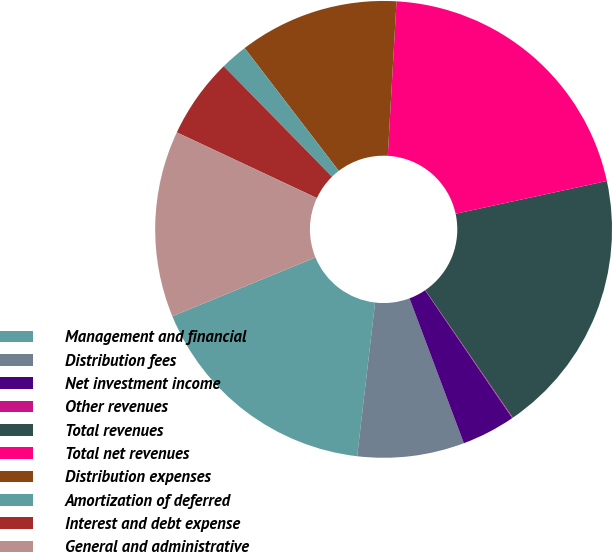Convert chart to OTSL. <chart><loc_0><loc_0><loc_500><loc_500><pie_chart><fcel>Management and financial<fcel>Distribution fees<fcel>Net investment income<fcel>Other revenues<fcel>Total revenues<fcel>Total net revenues<fcel>Distribution expenses<fcel>Amortization of deferred<fcel>Interest and debt expense<fcel>General and administrative<nl><fcel>16.94%<fcel>7.56%<fcel>3.81%<fcel>0.05%<fcel>18.82%<fcel>20.7%<fcel>11.31%<fcel>1.93%<fcel>5.68%<fcel>13.19%<nl></chart> 